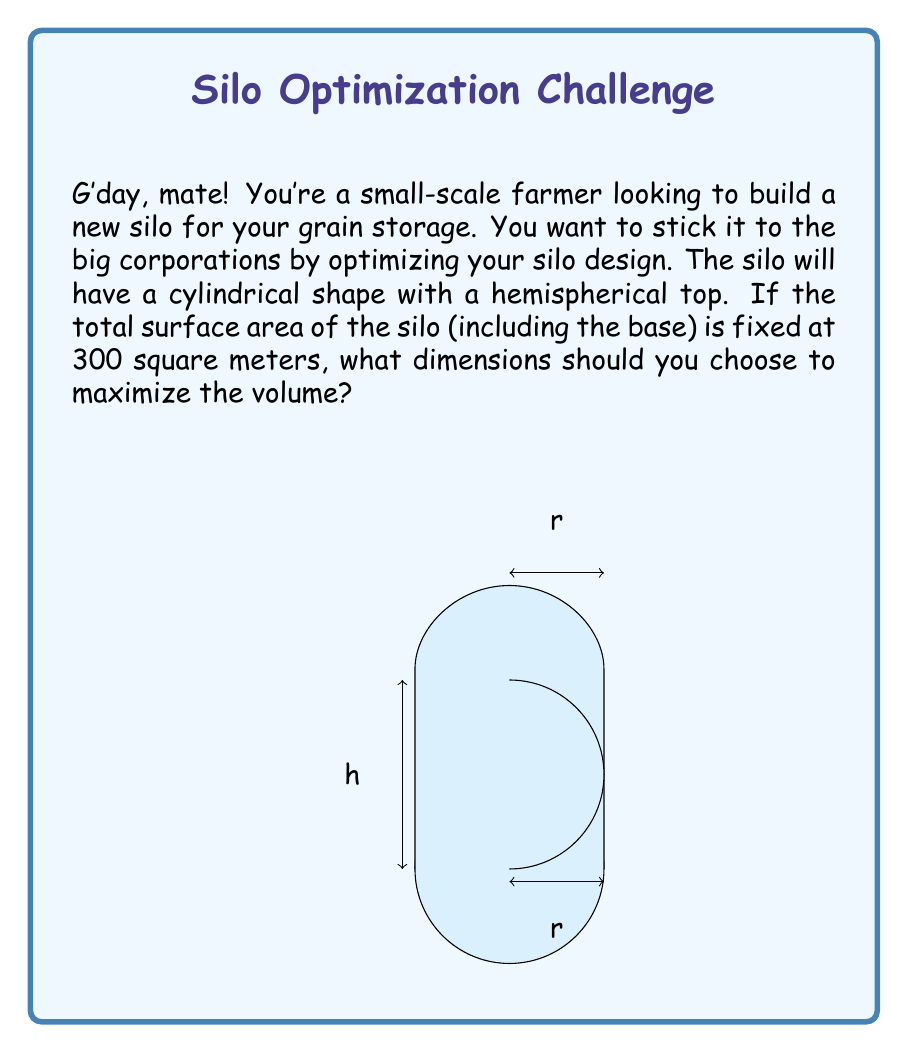Help me with this question. Let's approach this step-by-step:

1) Let $r$ be the radius of the cylinder and $h$ be its height.

2) The surface area of the silo consists of:
   - Circular base: $\pi r^2$
   - Cylindrical side: $2\pi rh$
   - Hemispherical top: $2\pi r^2$

3) The total surface area is given as 300 m². We can express this as an equation:
   $$\pi r^2 + 2\pi rh + 2\pi r^2 = 300$$
   $$\pi r^2 + 2\pi rh + 2\pi r^2 = 300$$
   $$3\pi r^2 + 2\pi rh = 300$$

4) The volume of the silo is:
   $$V = \pi r^2h + \frac{2}{3}\pi r^3$$

5) We want to maximize this volume. To do so, we need to express $h$ in terms of $r$ using the surface area equation:
   $$h = \frac{300 - 3\pi r^2}{2\pi r}$$

6) Substituting this into the volume equation:
   $$V = \pi r^2 (\frac{300 - 3\pi r^2}{2\pi r}) + \frac{2}{3}\pi r^3$$
   $$V = \frac{300r - 3\pi r^3}{2} + \frac{2}{3}\pi r^3$$
   $$V = 150r - \frac{3\pi r^3}{2} + \frac{2\pi r^3}{3}$$

7) To find the maximum, we differentiate V with respect to r and set it to zero:
   $$\frac{dV}{dr} = 150 - \frac{9\pi r^2}{2} + 2\pi r^2 = 0$$
   $$150 - \frac{5\pi r^2}{2} = 0$$
   $$r^2 = \frac{300}{5\pi} = \frac{60}{\pi}$$
   $$r = \sqrt{\frac{60}{\pi}} \approx 4.38$$

8) We can find h by substituting this value of r back into the equation from step 5:
   $$h = \frac{300 - 3\pi (\frac{60}{\pi})}{2\pi \sqrt{\frac{60}{\pi}}} = \sqrt{\frac{60}{\pi}} \approx 4.38$$

Therefore, to maximize the volume, the radius and height should both be approximately 4.38 meters.
Answer: $r = h = \sqrt{\frac{60}{\pi}} \approx 4.38$ meters 